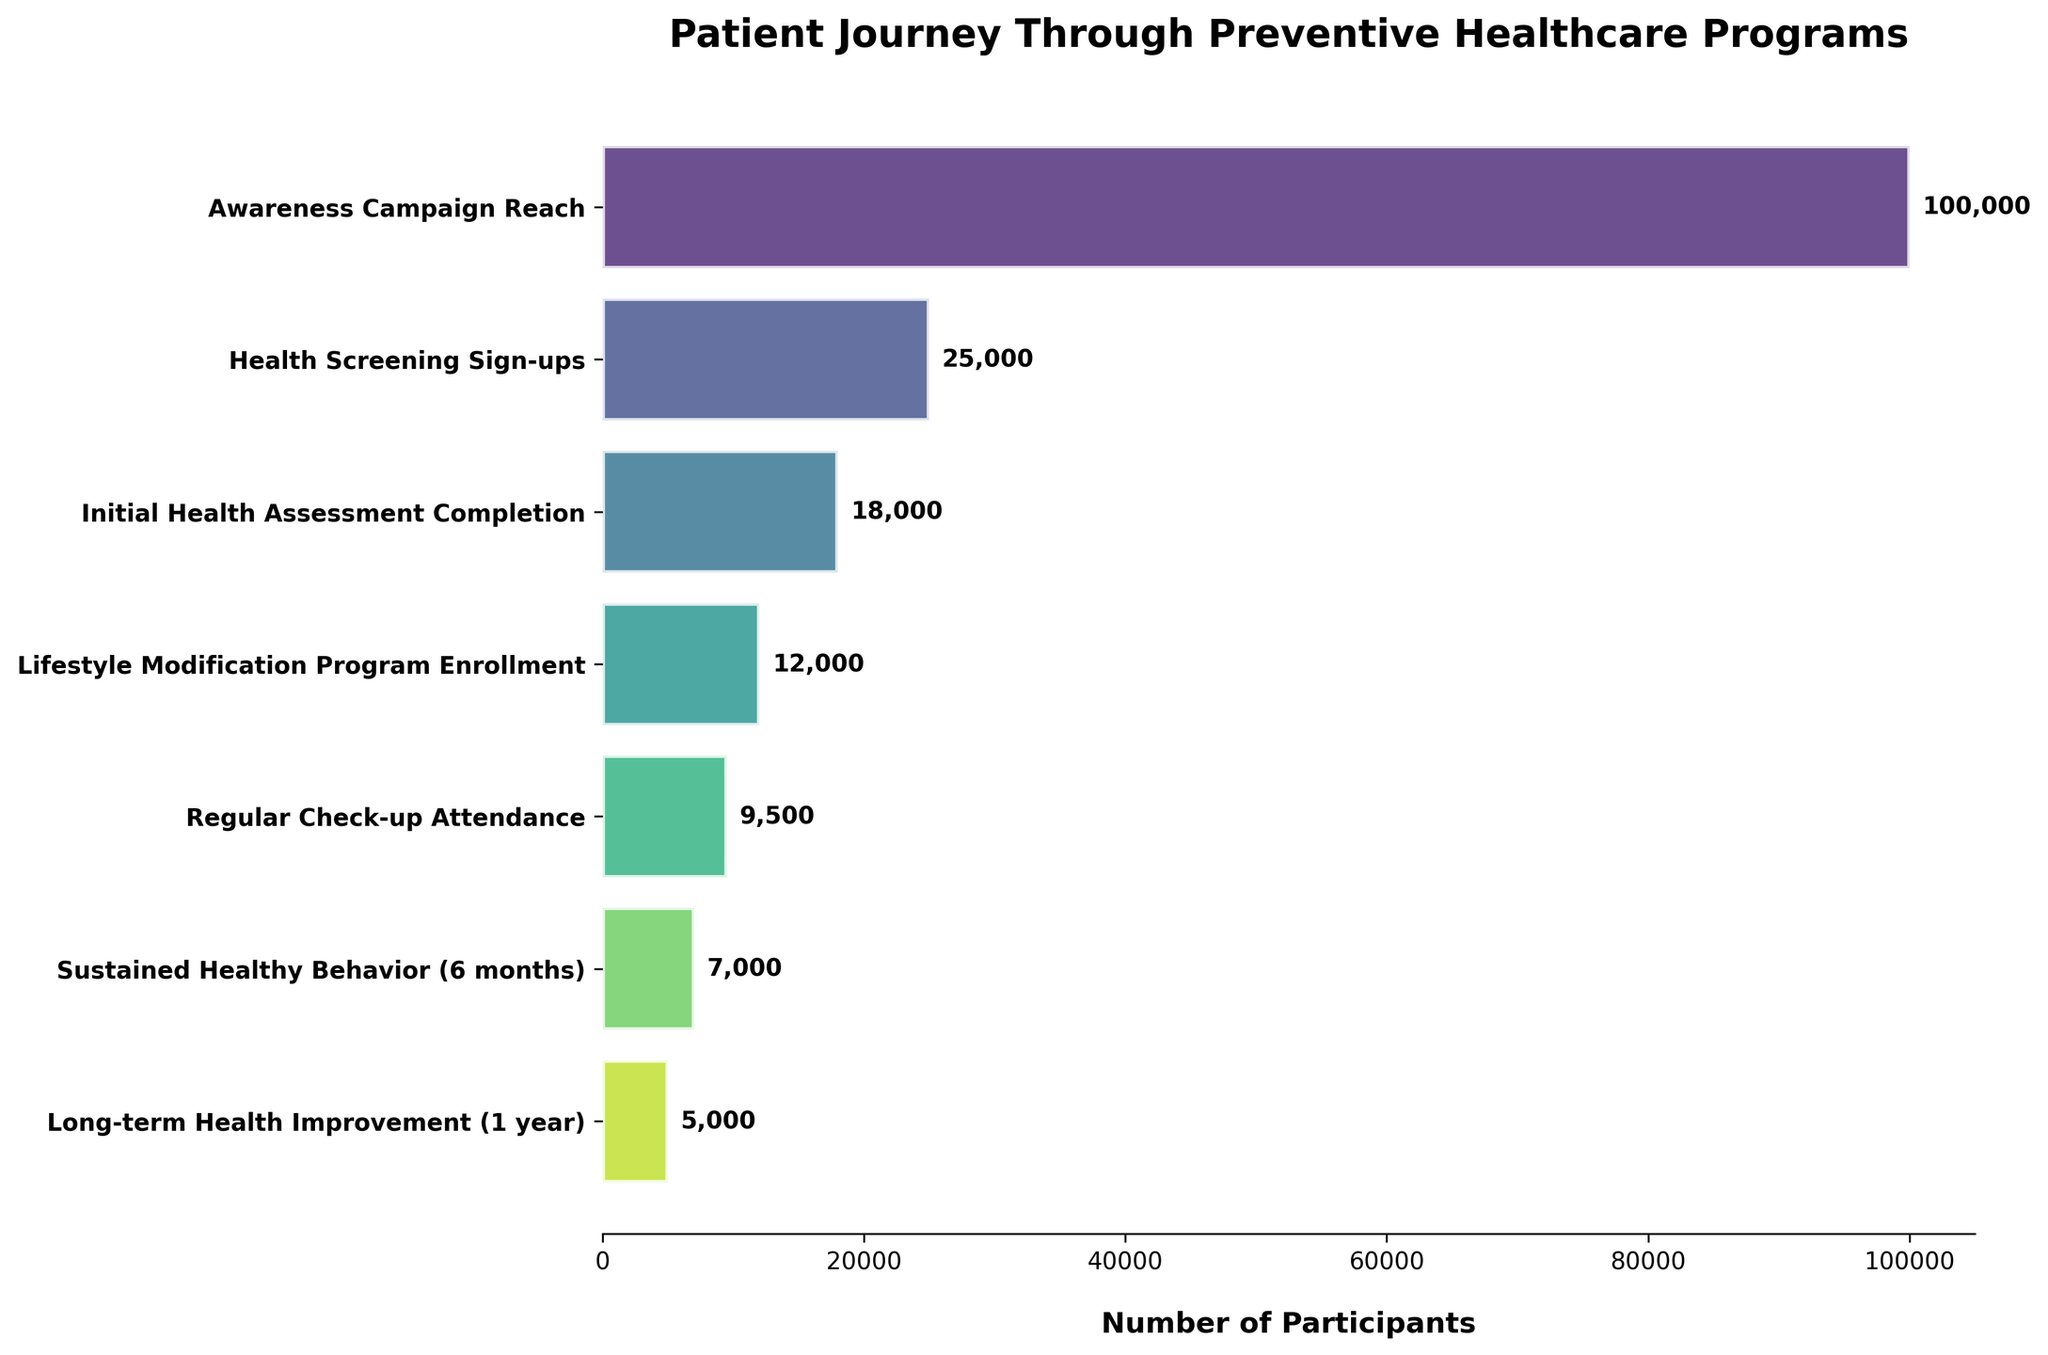What is the title of the figure? The title of the figure provides an overview of its content. Here, it states “Patient Journey Through Preventive Healthcare Programs.”
Answer: Patient Journey Through Preventive Healthcare Programs How many stages are there in the funnel chart? The funnel chart has a vertical list of stages on the y-axis, each representing a different step in the patient journey. Counting these stages will tell us how many there are.
Answer: 7 Which stage has the highest number of participants? By comparing the length of the bars horizontally, the longest bar represents the stage with the highest number of participants. The stage with the longest bar is “Awareness Campaign Reach” with 100,000 participants.
Answer: Awareness Campaign Reach What is the number of participants at the “Initial Health Assessment Completion” stage? Look at the bar corresponding to the “Initial Health Assessment Completion” stage and note the number at the end of the bar. The value is visually represented and also labeled as 18,000 participants.
Answer: 18,000 What is the decrease in the number of participants from “Health Screening Sign-ups” to “Regular Check-up Attendance”? Subtract the number of participants in “Regular Check-up Attendance” (9,500) from those in “Health Screening Sign-ups” (25,000).
Answer: 15,500 participants decrease What is the average number of participants across all stages? Sum all participants across the stages (100,000 + 25,000 + 18,000 + 12,000 + 9,500 + 7,000 + 5,000) and divide by the number of stages (7). (176,500 / 7)
Answer: 25,214 participants Which stage shows the most considerable drop in participant numbers compared to the previous stage? By comparing the differences between consecutive stages, the largest drop is from “Awareness Campaign Reach” (100,000) to “Health Screening Sign-ups” (25,000), which is a decrease of 75,000 participants.
Answer: Health Screening Sign-ups What percentage of people from the “Lifestyle Modification Program Enrollment” stage continue to the “Regular Check-up Attendance” stage? Divide the number of participants at the “Regular Check-up Attendance” stage by the “Lifestyle Modification Program Enrollment” stage and multiply by 100. (9,500 / 12,000) * 100.
Answer: 79.17% Which two stages have the closest number of participants? Compare the number of participants across all stages, and note that the smallest difference occurs between “Lifestyle Modification Program Enrollment” (12,000) and “Regular Check-up Attendance” (9,500), a difference of 2,500.
Answer: Lifestyle Modification Program Enrollment and Regular Check-up Attendance What is the overall retention rate from the “Awareness Campaign Reach” to “Long-term Health Improvement (1 year)”? Calculate the percentage by dividing the number of participants at the “Long-term Health Improvement (1 year)” stage by the “Awareness Campaign Reach” stage and multiply by 100. (5,000 / 100,000) * 100.
Answer: 5% 